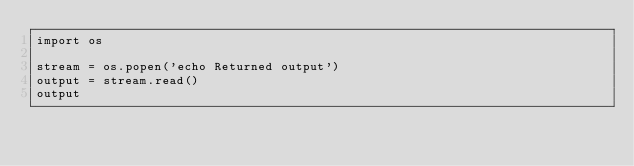<code> <loc_0><loc_0><loc_500><loc_500><_Python_>import os

stream = os.popen('echo Returned output')
output = stream.read()
output
</code> 